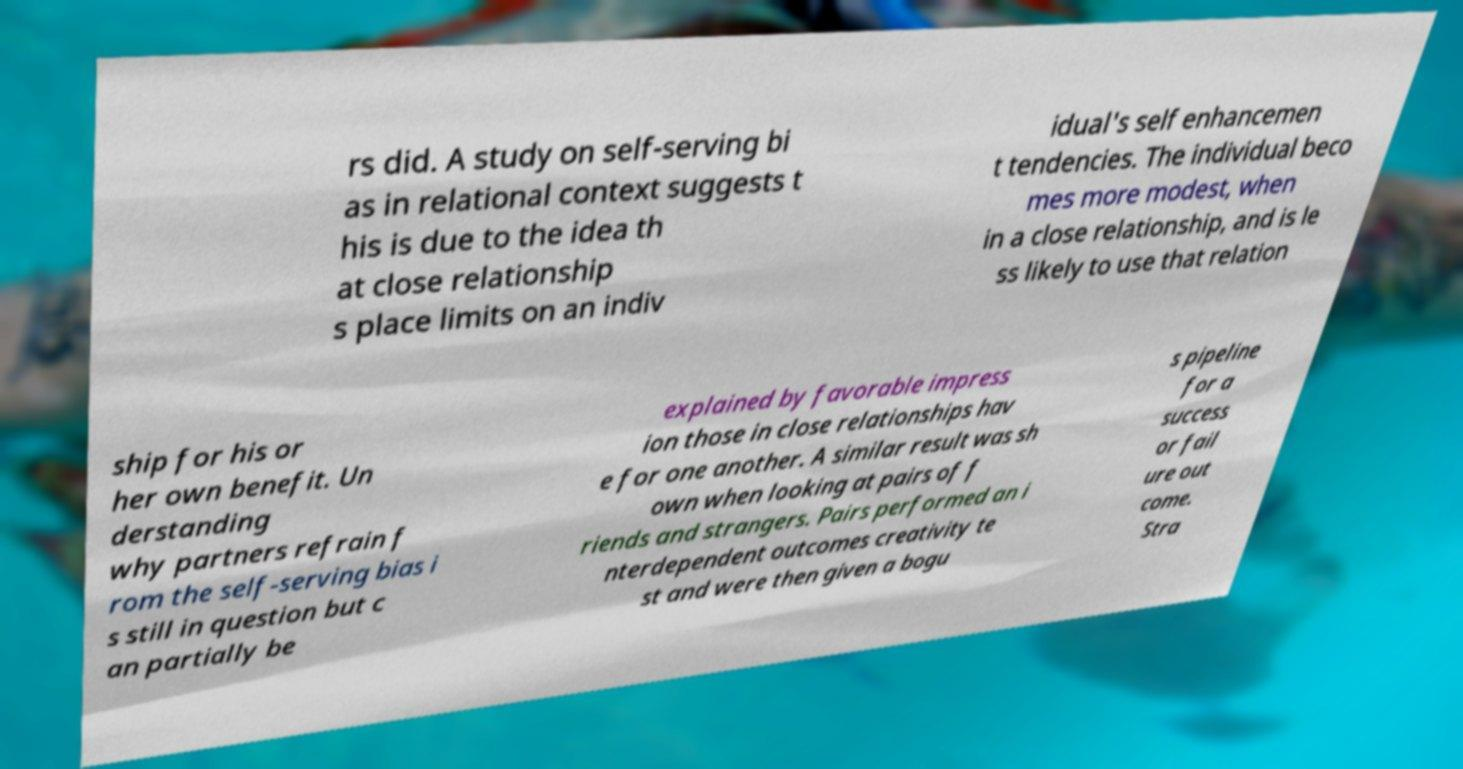Please read and relay the text visible in this image. What does it say? rs did. A study on self-serving bi as in relational context suggests t his is due to the idea th at close relationship s place limits on an indiv idual's self enhancemen t tendencies. The individual beco mes more modest, when in a close relationship, and is le ss likely to use that relation ship for his or her own benefit. Un derstanding why partners refrain f rom the self-serving bias i s still in question but c an partially be explained by favorable impress ion those in close relationships hav e for one another. A similar result was sh own when looking at pairs of f riends and strangers. Pairs performed an i nterdependent outcomes creativity te st and were then given a bogu s pipeline for a success or fail ure out come. Stra 